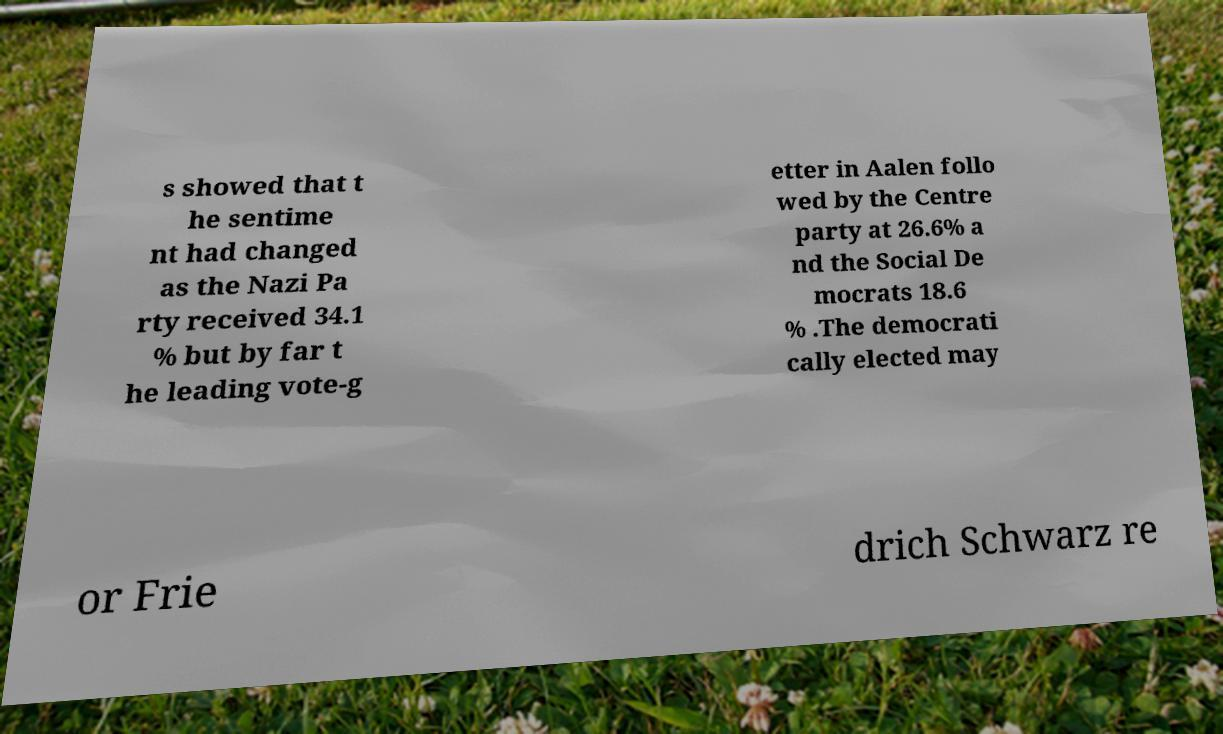What messages or text are displayed in this image? I need them in a readable, typed format. s showed that t he sentime nt had changed as the Nazi Pa rty received 34.1 % but by far t he leading vote-g etter in Aalen follo wed by the Centre party at 26.6% a nd the Social De mocrats 18.6 % .The democrati cally elected may or Frie drich Schwarz re 